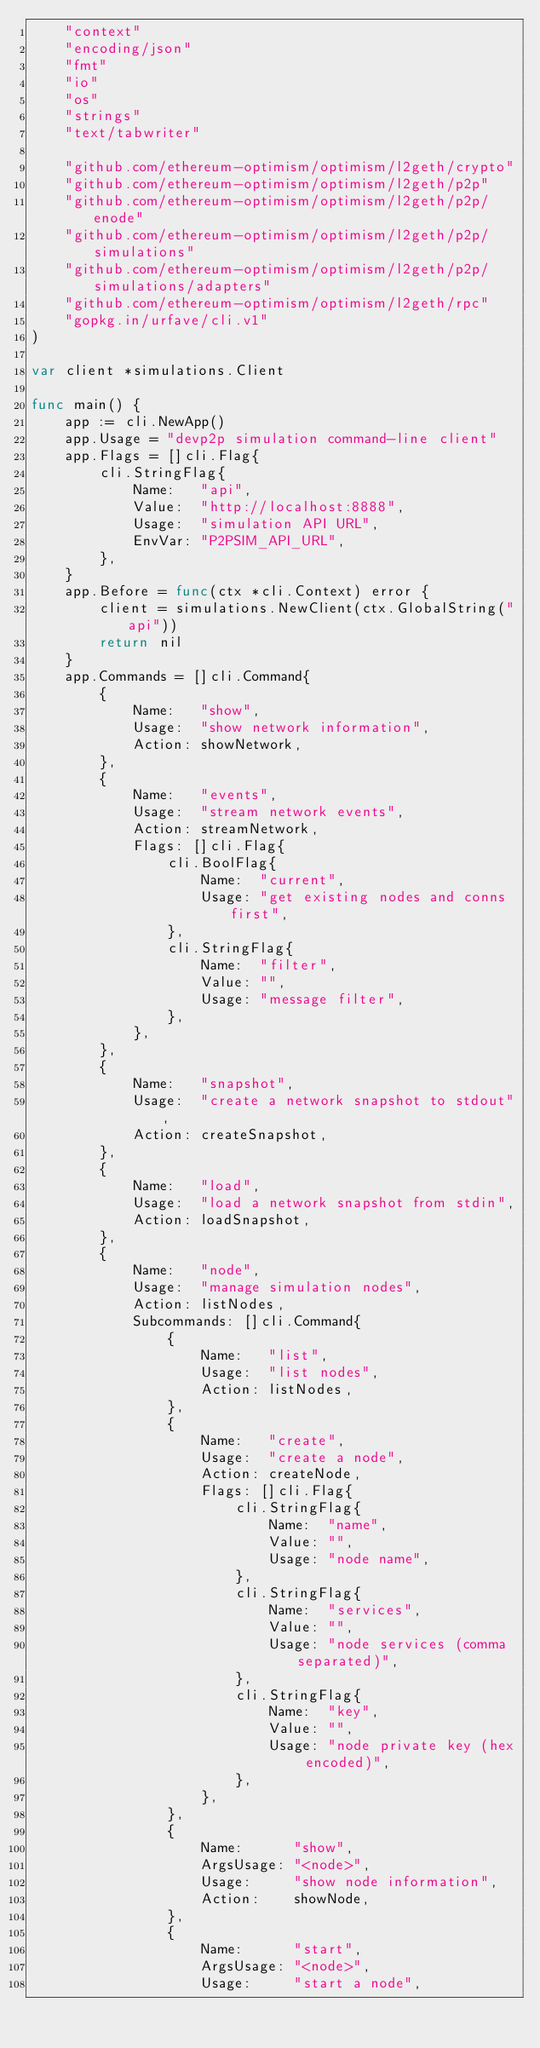<code> <loc_0><loc_0><loc_500><loc_500><_Go_>	"context"
	"encoding/json"
	"fmt"
	"io"
	"os"
	"strings"
	"text/tabwriter"

	"github.com/ethereum-optimism/optimism/l2geth/crypto"
	"github.com/ethereum-optimism/optimism/l2geth/p2p"
	"github.com/ethereum-optimism/optimism/l2geth/p2p/enode"
	"github.com/ethereum-optimism/optimism/l2geth/p2p/simulations"
	"github.com/ethereum-optimism/optimism/l2geth/p2p/simulations/adapters"
	"github.com/ethereum-optimism/optimism/l2geth/rpc"
	"gopkg.in/urfave/cli.v1"
)

var client *simulations.Client

func main() {
	app := cli.NewApp()
	app.Usage = "devp2p simulation command-line client"
	app.Flags = []cli.Flag{
		cli.StringFlag{
			Name:   "api",
			Value:  "http://localhost:8888",
			Usage:  "simulation API URL",
			EnvVar: "P2PSIM_API_URL",
		},
	}
	app.Before = func(ctx *cli.Context) error {
		client = simulations.NewClient(ctx.GlobalString("api"))
		return nil
	}
	app.Commands = []cli.Command{
		{
			Name:   "show",
			Usage:  "show network information",
			Action: showNetwork,
		},
		{
			Name:   "events",
			Usage:  "stream network events",
			Action: streamNetwork,
			Flags: []cli.Flag{
				cli.BoolFlag{
					Name:  "current",
					Usage: "get existing nodes and conns first",
				},
				cli.StringFlag{
					Name:  "filter",
					Value: "",
					Usage: "message filter",
				},
			},
		},
		{
			Name:   "snapshot",
			Usage:  "create a network snapshot to stdout",
			Action: createSnapshot,
		},
		{
			Name:   "load",
			Usage:  "load a network snapshot from stdin",
			Action: loadSnapshot,
		},
		{
			Name:   "node",
			Usage:  "manage simulation nodes",
			Action: listNodes,
			Subcommands: []cli.Command{
				{
					Name:   "list",
					Usage:  "list nodes",
					Action: listNodes,
				},
				{
					Name:   "create",
					Usage:  "create a node",
					Action: createNode,
					Flags: []cli.Flag{
						cli.StringFlag{
							Name:  "name",
							Value: "",
							Usage: "node name",
						},
						cli.StringFlag{
							Name:  "services",
							Value: "",
							Usage: "node services (comma separated)",
						},
						cli.StringFlag{
							Name:  "key",
							Value: "",
							Usage: "node private key (hex encoded)",
						},
					},
				},
				{
					Name:      "show",
					ArgsUsage: "<node>",
					Usage:     "show node information",
					Action:    showNode,
				},
				{
					Name:      "start",
					ArgsUsage: "<node>",
					Usage:     "start a node",</code> 